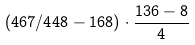<formula> <loc_0><loc_0><loc_500><loc_500>( 4 6 7 / 4 4 8 - 1 6 8 ) \cdot \frac { 1 3 6 - 8 } { 4 }</formula> 